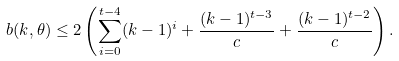Convert formula to latex. <formula><loc_0><loc_0><loc_500><loc_500>b ( k , \theta ) \leq 2 \left ( \sum _ { i = 0 } ^ { t - 4 } ( k - 1 ) ^ { i } + \frac { ( k - 1 ) ^ { t - 3 } } { c } + \frac { ( k - 1 ) ^ { t - 2 } } { c } \right ) .</formula> 